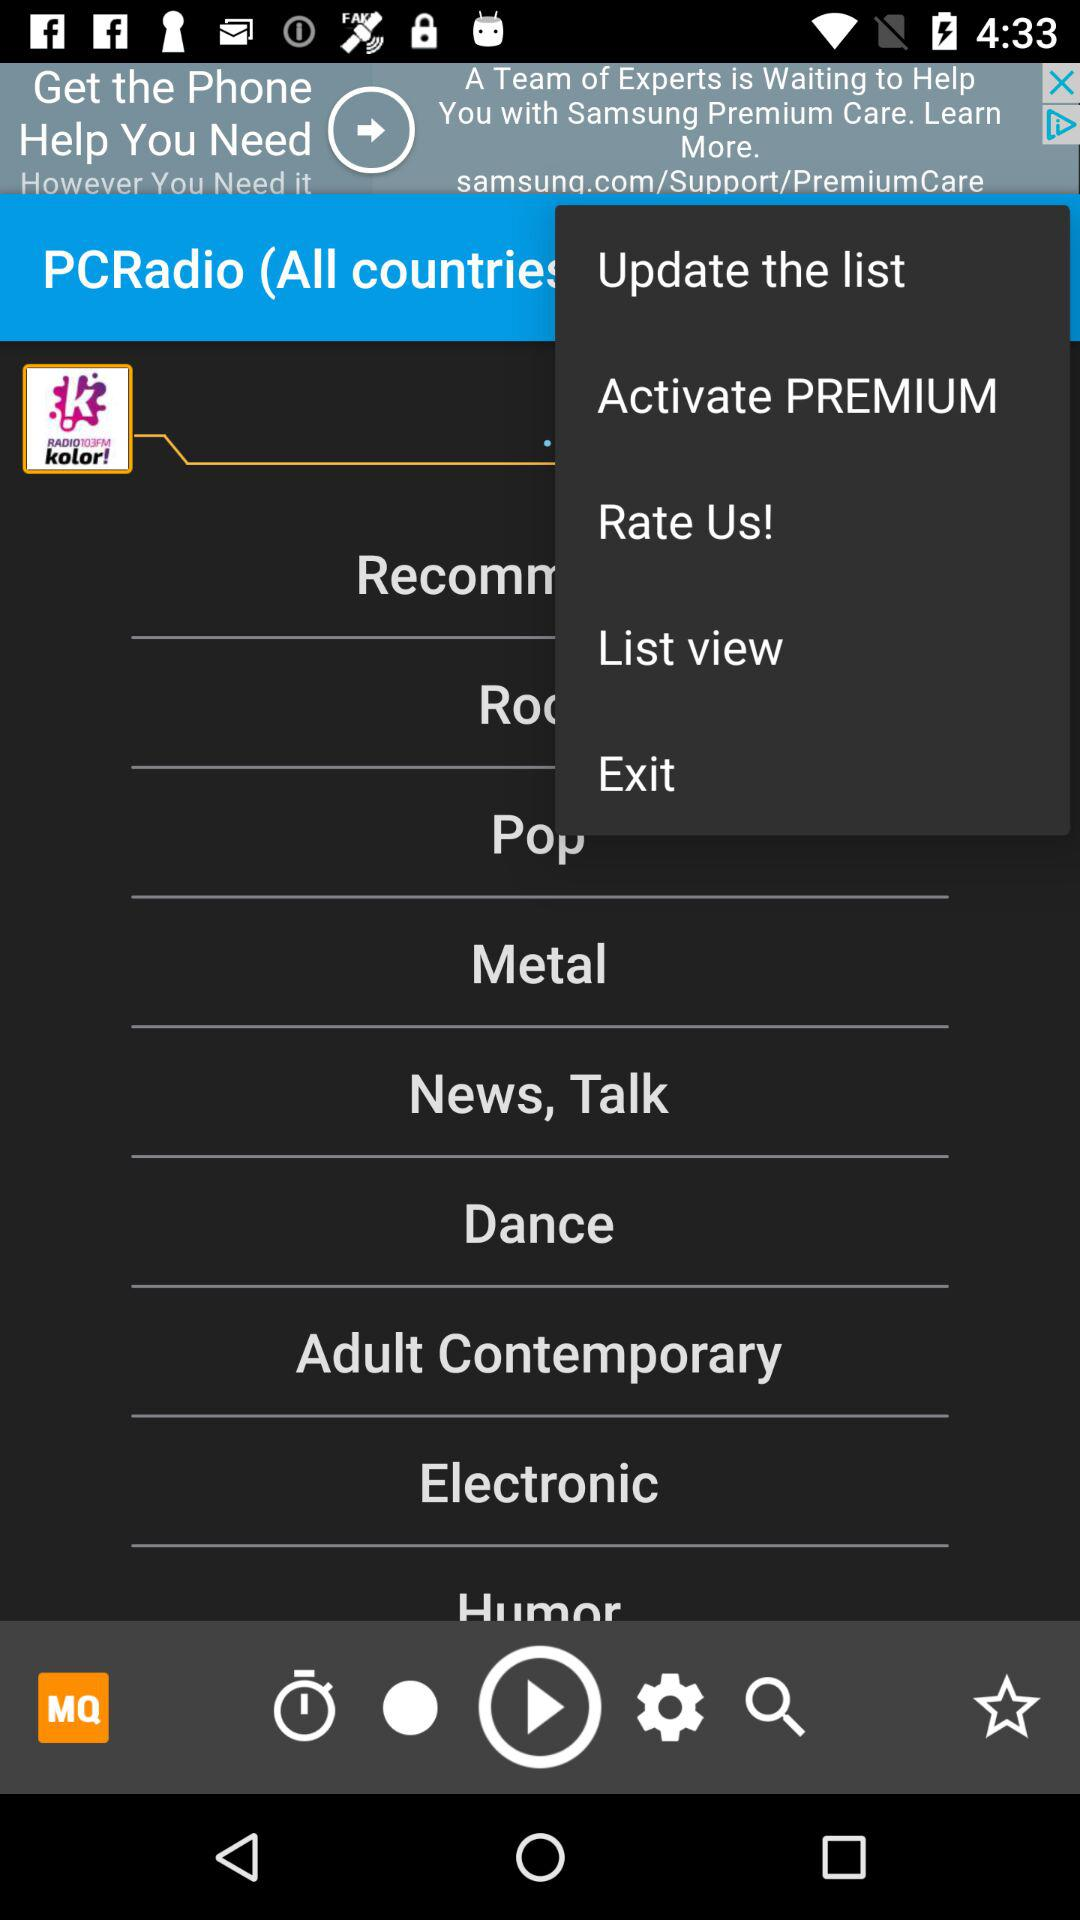How many items are there in "Dance"?
When the provided information is insufficient, respond with <no answer>. <no answer> 